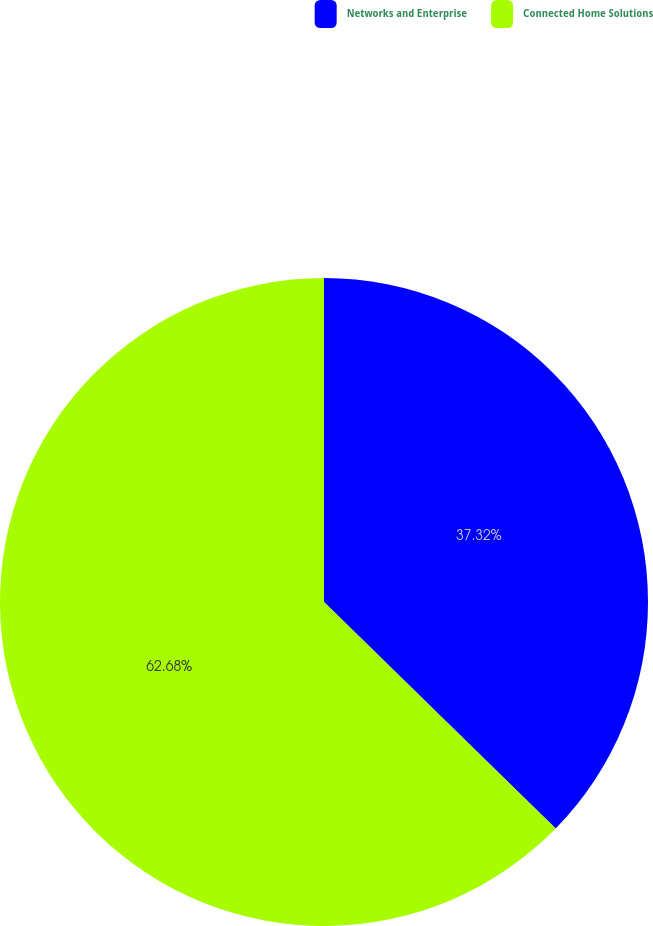Convert chart. <chart><loc_0><loc_0><loc_500><loc_500><pie_chart><fcel>Networks and Enterprise<fcel>Connected Home Solutions<nl><fcel>37.32%<fcel>62.68%<nl></chart> 